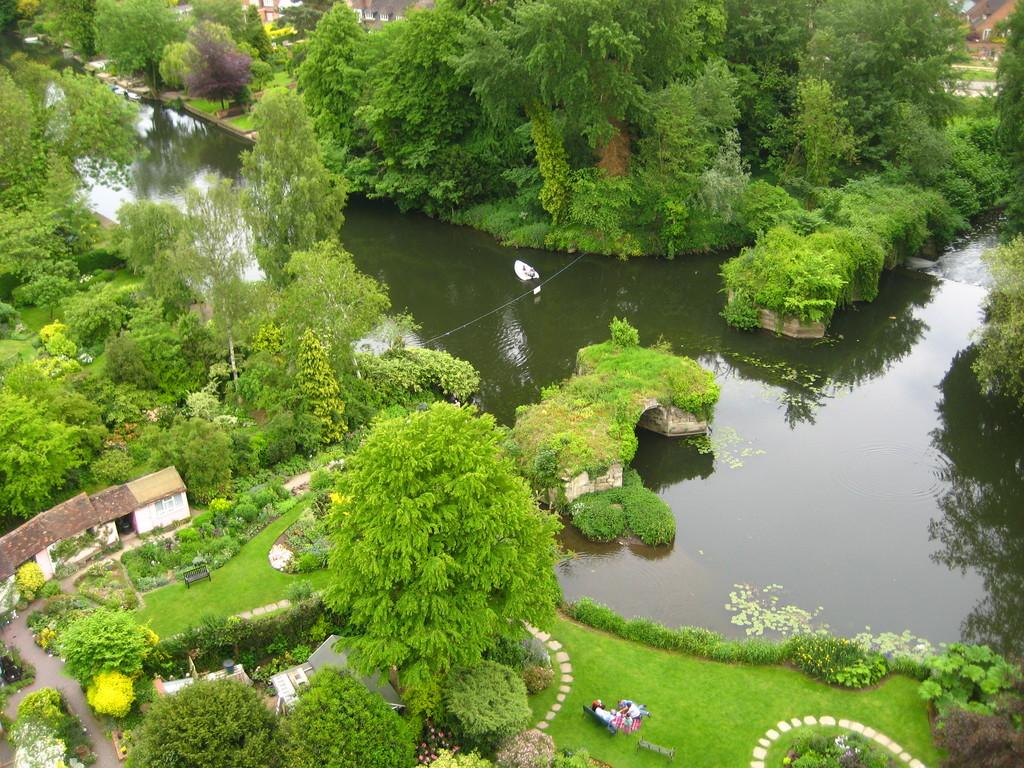What is one of the natural elements present in the image? There is water in the image. What type of vegetation can be seen in the image? There is grass, plants, and trees in the image. What type of structures are visible in the image? There are houses and a road in the image. What type of seating is available in the image? There are benches in the image. Are there any people present in the image? Yes, there are people in the image. What is the person writing on their arm in the image? There is no person writing on their arm in the image. 